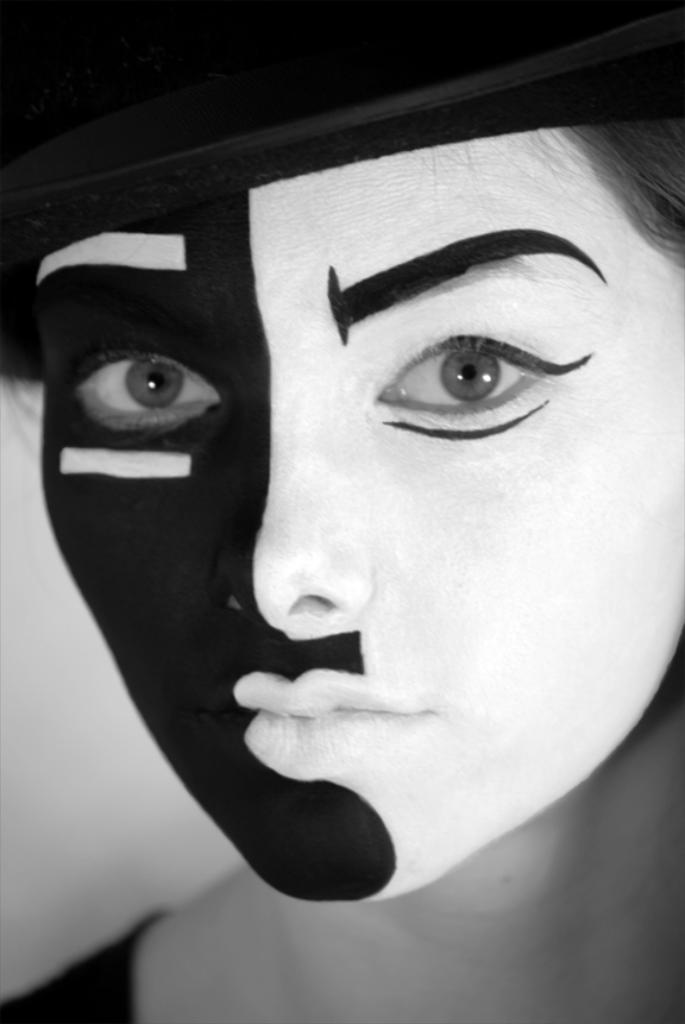What is the color scheme of the image? The image is black and white. Can you describe the person in the image? There is a person in the image, and they are wearing a mask and a cap. How many snakes are wrapped around the person's neck in the image? There are no snakes present in the image; the person is wearing a mask and a cap. What type of toothbrush is the person holding in the image? There is no toothbrush present in the image; the person is wearing a mask and a cap. 